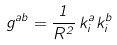Convert formula to latex. <formula><loc_0><loc_0><loc_500><loc_500>g ^ { a b } = \frac { 1 } { R ^ { 2 } } \, k ^ { a } _ { i } k ^ { b } _ { i }</formula> 